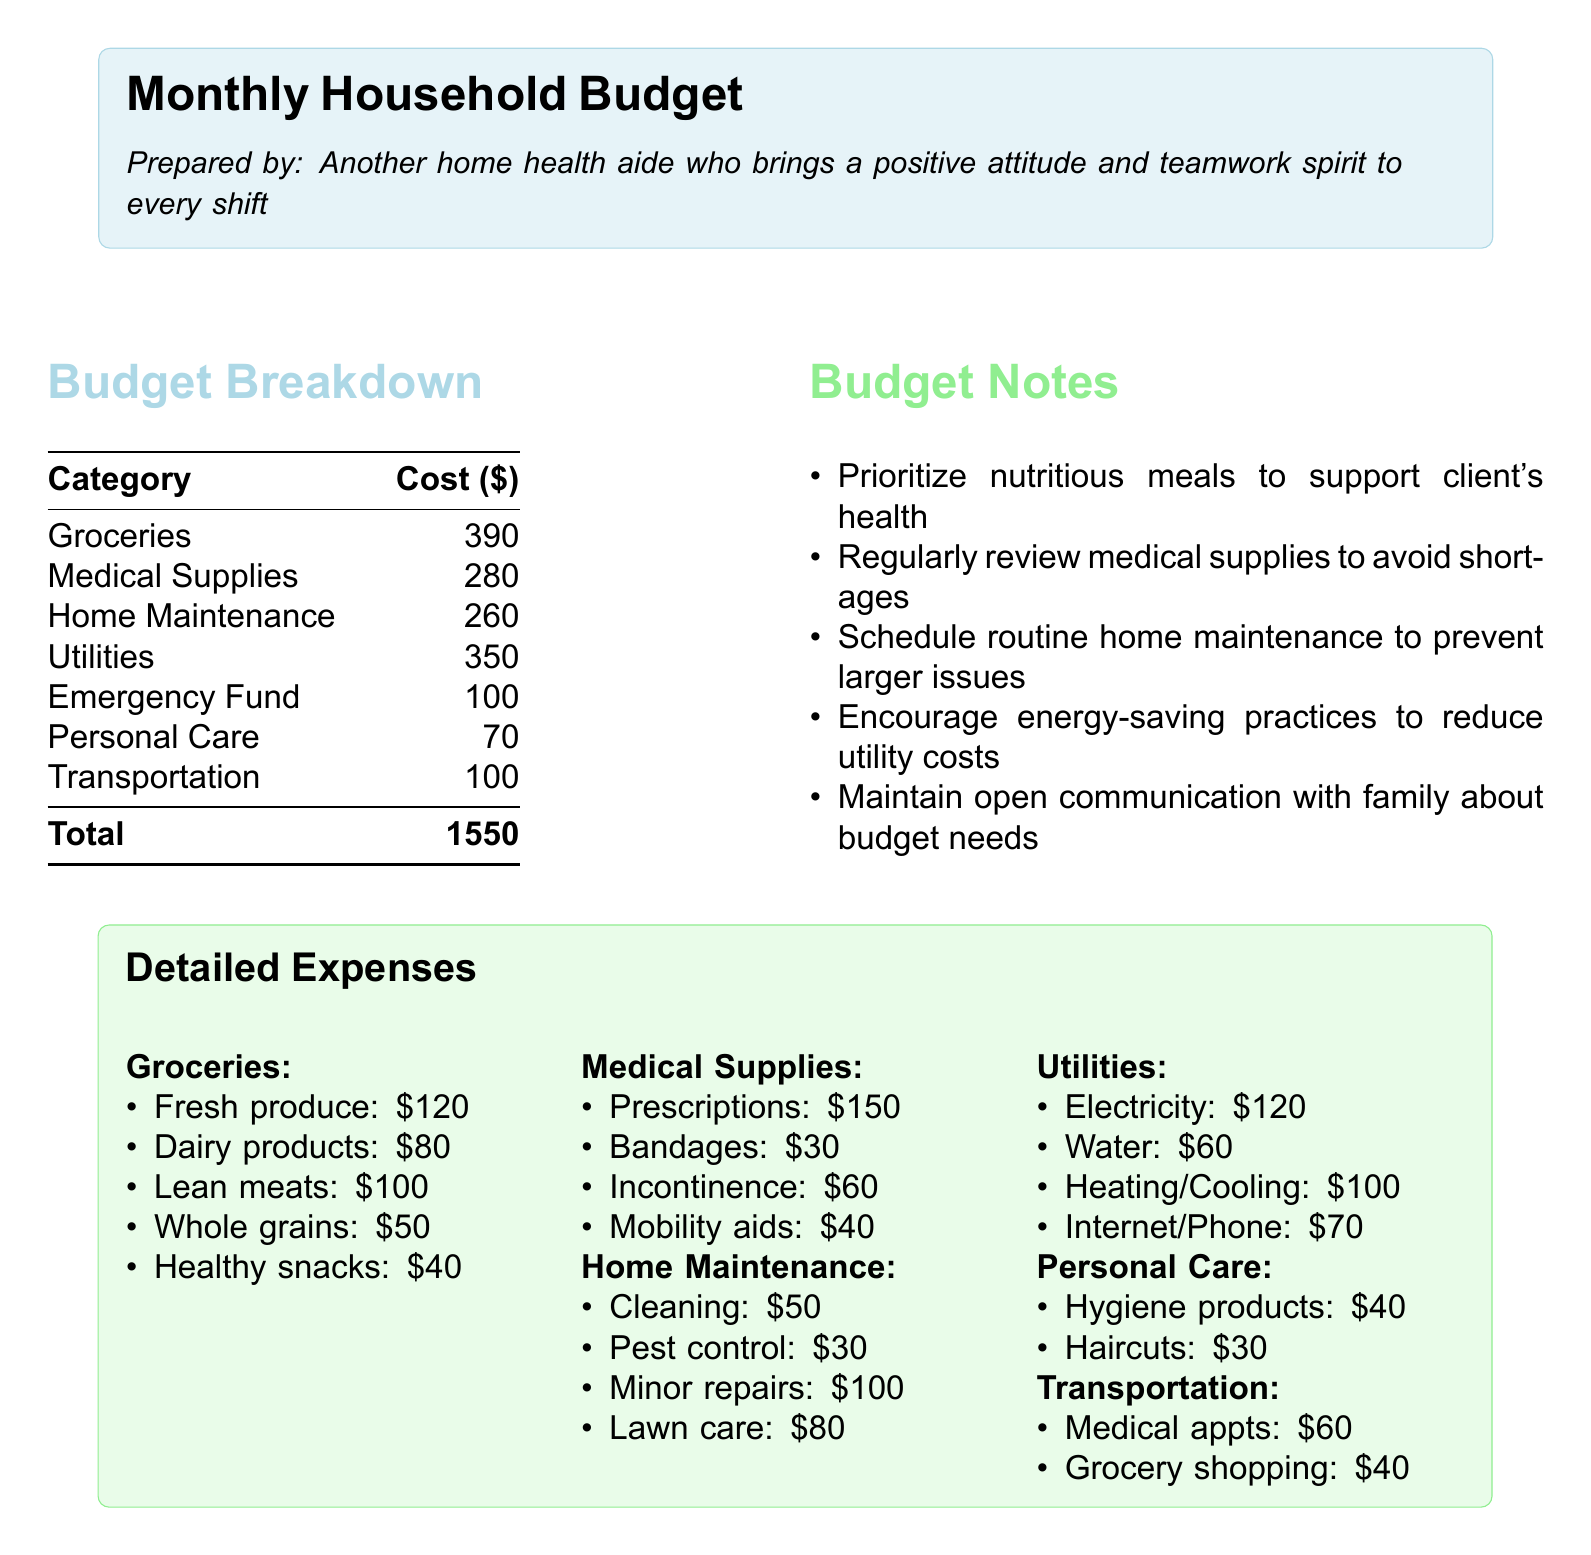What is the total cost of groceries? The total cost of groceries is listed as $390.
Answer: $390 How much is allocated for medical supplies? Medical supplies are budgeted at $280.
Answer: $280 What is the budget for home maintenance? The budget for home maintenance is $260.
Answer: $260 What percentage of the total budget is allocated to utilities? Utilities account for $350 out of the total $1550, which simplifies to approximately 22.58%.
Answer: 22.58% How much is set aside for the emergency fund? The document specifies an emergency fund of $100.
Answer: $100 What is the cost of fresh produce per month? Fresh produce costs $120 per month as per the detailed expenses.
Answer: $120 How much is budgeted for prescriptions? The budget for prescriptions under medical supplies is $150.
Answer: $150 What is the total expenditure on personal care? The total expenditure on personal care is $70.
Answer: $70 What maintenance activity costs the most? The highest maintenance cost is minor repairs at $100.
Answer: $100 